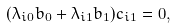<formula> <loc_0><loc_0><loc_500><loc_500>( \lambda _ { i 0 } b _ { 0 } + \lambda _ { i 1 } b _ { 1 } ) c _ { i 1 } = 0 ,</formula> 